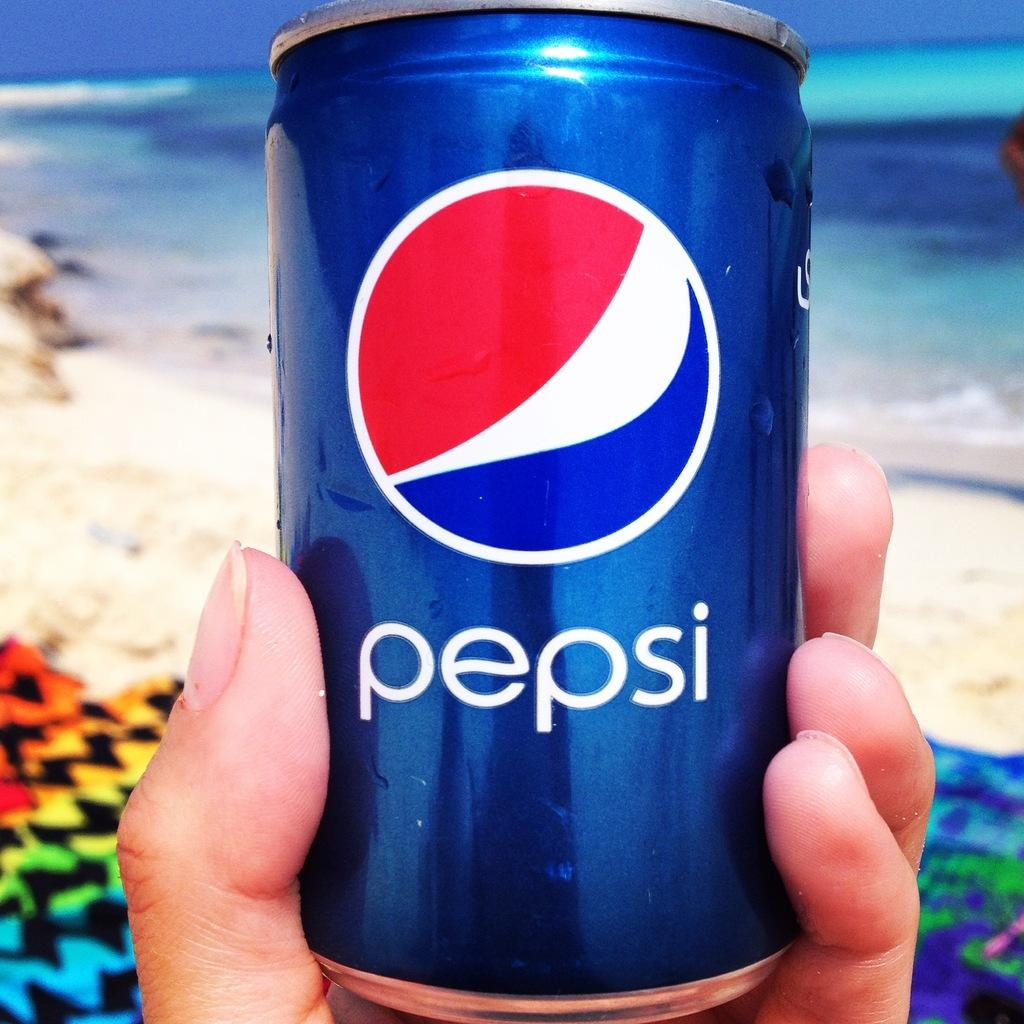<image>
Provide a brief description of the given image. a person is holding a can of pepsi near the beach 